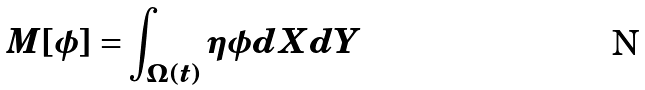Convert formula to latex. <formula><loc_0><loc_0><loc_500><loc_500>M [ \phi ] = \int _ { \Omega ( t ) } \eta \phi d X d Y</formula> 